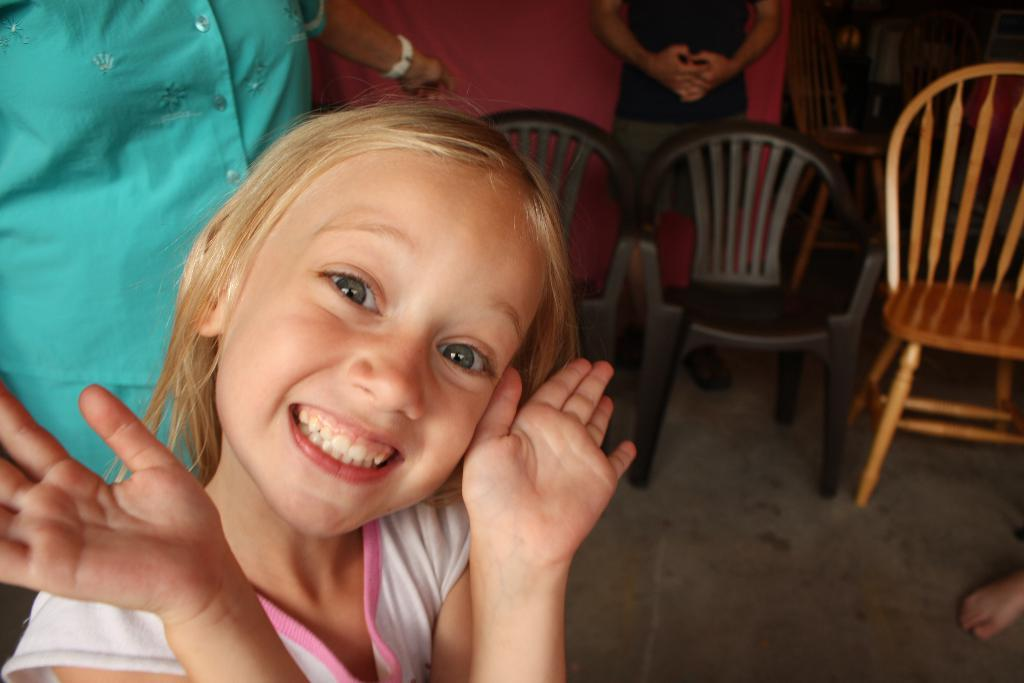Who is the main subject in the image? There is a girl in the image. What is the girl's expression in the image? The girl is smiling in the image. What can be seen in the background of the image? There is a group of people and chairs in the background of the image. What type of cart is being used by the girl in the image? There is no cart present in the image; the girl is not using any cart. 